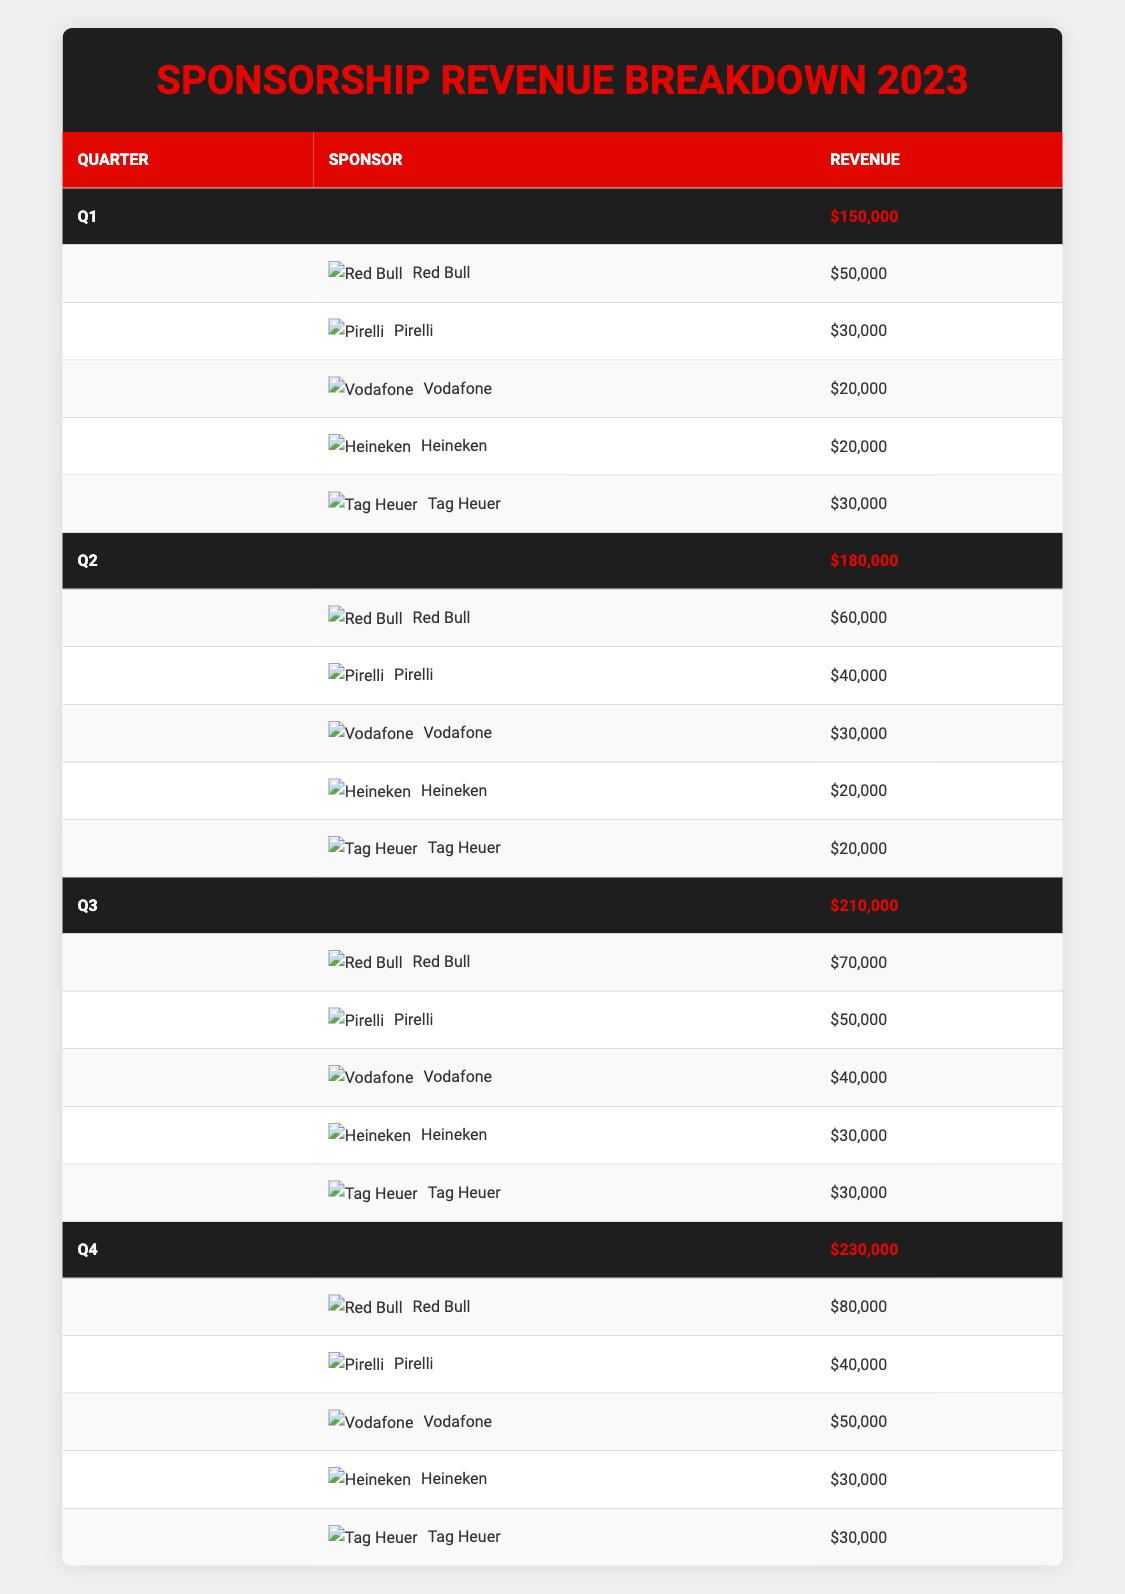What was the total revenue from sponsorships in Q2? In the table, the total revenue for Q2 is stated directly under the totals row for that quarter. It shows $180,000 as the total revenue for Q2.
Answer: 180,000 Which sponsor contributed the most revenue in Q3? In Q3, the revenue contributions are listed for each sponsor. Red Bull shows a revenue of $70,000, which is higher than any other sponsor's contribution in that quarter.
Answer: Red Bull How much did Vodafone contribute across all four quarters? To find Vodafone's total contribution, I add up each quarter's revenue from the table: Q1 ($20,000) + Q2 ($30,000) + Q3 ($40,000) + Q4 ($50,000) = $140,000.
Answer: 140,000 Did Heineken’s contribution increase or decrease from Q1 to Q4? Heineken contributed $20,000 in Q1 and $30,000 in Q4. Since $30,000 is greater than $20,000, the contribution increased.
Answer: Increase What is the average revenue generated by Tag Heuer per quarter? From the table, Tag Heuer's contributions are: Q1 ($30,000), Q2 ($20,000), Q3 ($30,000), Q4 ($30,000). The sum is $30,000 + $20,000 + $30,000 + $30,000 = $110,000. Dividing by 4 quarters: $110,000 / 4 = $27,500.
Answer: 27,500 How much more did Red Bull earn in Q4 compared to Q1? The revenue for Red Bull in Q4 is $80,000 and in Q1 it is $50,000. The difference is $80,000 - $50,000 = $30,000, which means Red Bull earned $30,000 more in Q4 compared to Q1.
Answer: 30,000 Is the total revenue in Q3 greater than the total for Q2? The total revenue for Q3 is $210,000 while the total for Q2 is $180,000. Since $210,000 is greater than $180,000, the statement is true.
Answer: Yes What was the total sponsorship revenue for the entire year of 2023? To calculate the total revenue for the year, I add the total revenues for each quarter: Q1 ($150,000) + Q2 ($180,000) + Q3 ($210,000) + Q4 ($230,000) = $770,000.
Answer: 770,000 